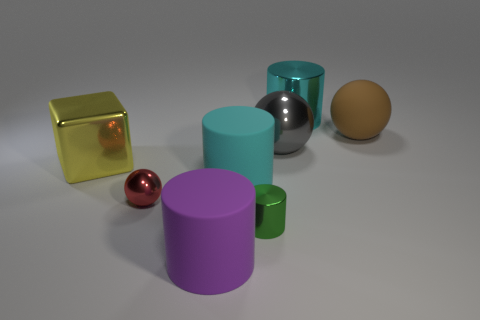There is a cyan shiny cylinder; how many objects are to the right of it?
Your answer should be very brief. 1. How many things are either big things in front of the cyan rubber cylinder or yellow metal objects?
Your answer should be compact. 2. Is the number of large objects right of the gray thing greater than the number of large metallic things that are to the right of the block?
Keep it short and to the point. No. What size is the other cylinder that is the same color as the big metallic cylinder?
Give a very brief answer. Large. There is a brown matte sphere; is it the same size as the cyan cylinder that is behind the gray metallic thing?
Offer a very short reply. Yes. How many cubes are either brown objects or green metallic objects?
Keep it short and to the point. 0. There is a gray thing that is made of the same material as the large yellow object; what is its size?
Provide a short and direct response. Large. There is a cylinder that is in front of the small green cylinder; is it the same size as the ball that is to the left of the cyan rubber cylinder?
Make the answer very short. No. What number of objects are brown matte cylinders or tiny metal objects?
Ensure brevity in your answer.  2. What shape is the tiny green thing?
Offer a terse response. Cylinder. 